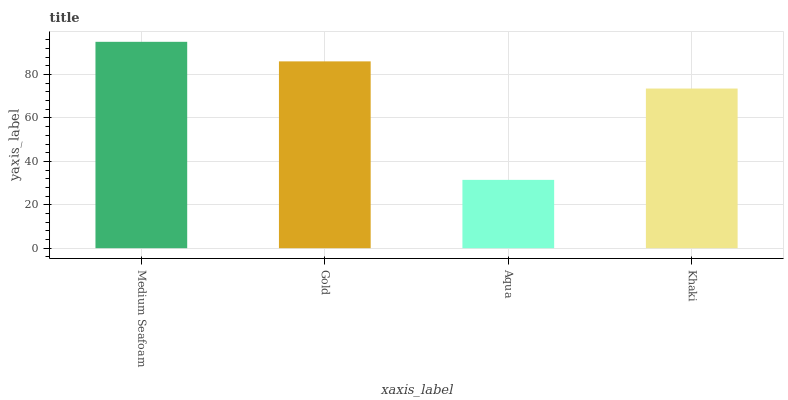Is Aqua the minimum?
Answer yes or no. Yes. Is Medium Seafoam the maximum?
Answer yes or no. Yes. Is Gold the minimum?
Answer yes or no. No. Is Gold the maximum?
Answer yes or no. No. Is Medium Seafoam greater than Gold?
Answer yes or no. Yes. Is Gold less than Medium Seafoam?
Answer yes or no. Yes. Is Gold greater than Medium Seafoam?
Answer yes or no. No. Is Medium Seafoam less than Gold?
Answer yes or no. No. Is Gold the high median?
Answer yes or no. Yes. Is Khaki the low median?
Answer yes or no. Yes. Is Aqua the high median?
Answer yes or no. No. Is Medium Seafoam the low median?
Answer yes or no. No. 